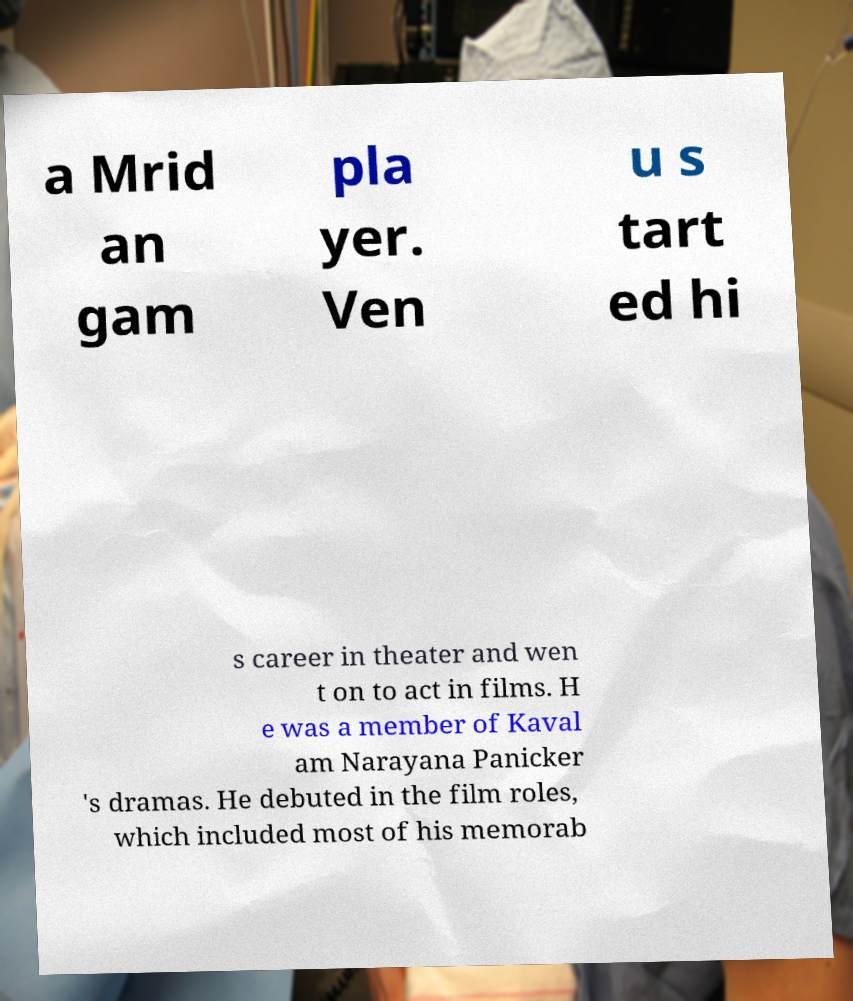Please identify and transcribe the text found in this image. a Mrid an gam pla yer. Ven u s tart ed hi s career in theater and wen t on to act in films. H e was a member of Kaval am Narayana Panicker 's dramas. He debuted in the film roles, which included most of his memorab 